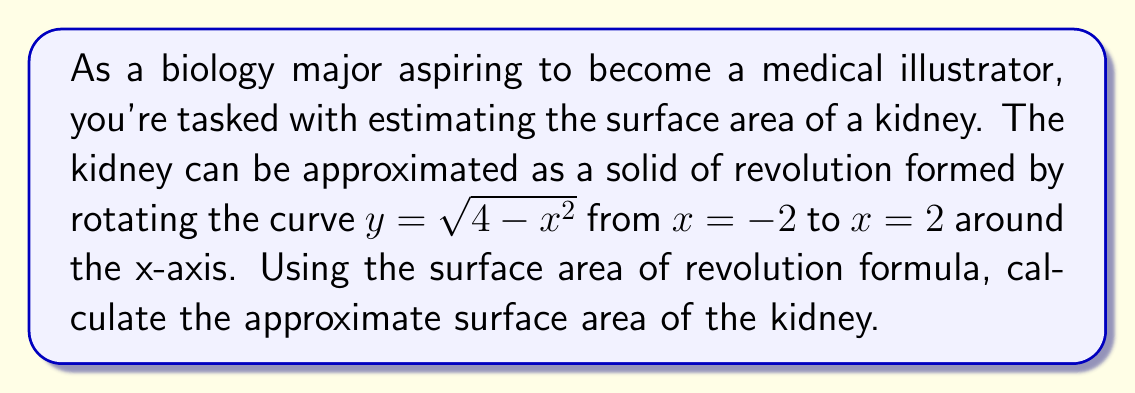What is the answer to this math problem? To solve this problem, we'll use the surface area of revolution formula:

$$S = 2\pi \int_a^b y \sqrt{1 + (\frac{dy}{dx})^2} dx$$

Where:
- $y = \sqrt{4 - x^2}$
- $a = -2$ and $b = 2$

Steps:
1) First, we need to find $\frac{dy}{dx}$:
   $$\frac{dy}{dx} = -\frac{x}{\sqrt{4-x^2}}$$

2) Now, let's substitute these into the formula:
   $$S = 2\pi \int_{-2}^2 \sqrt{4-x^2} \sqrt{1 + (\frac{-x}{\sqrt{4-x^2}})^2} dx$$

3) Simplify the expression under the square root:
   $$S = 2\pi \int_{-2}^2 \sqrt{4-x^2} \sqrt{1 + \frac{x^2}{4-x^2}} dx$$
   $$S = 2\pi \int_{-2}^2 \sqrt{4-x^2} \sqrt{\frac{4}{4-x^2}} dx$$
   $$S = 2\pi \int_{-2}^2 \sqrt{4} dx$$
   $$S = 4\pi \int_{-2}^2 dx$$

4) Evaluate the integral:
   $$S = 4\pi [x]_{-2}^2$$
   $$S = 4\pi (2 - (-2))$$
   $$S = 4\pi (4)$$
   $$S = 16\pi$$

Therefore, the surface area of the kidney is $16\pi$ square units.
Answer: $16\pi$ square units 